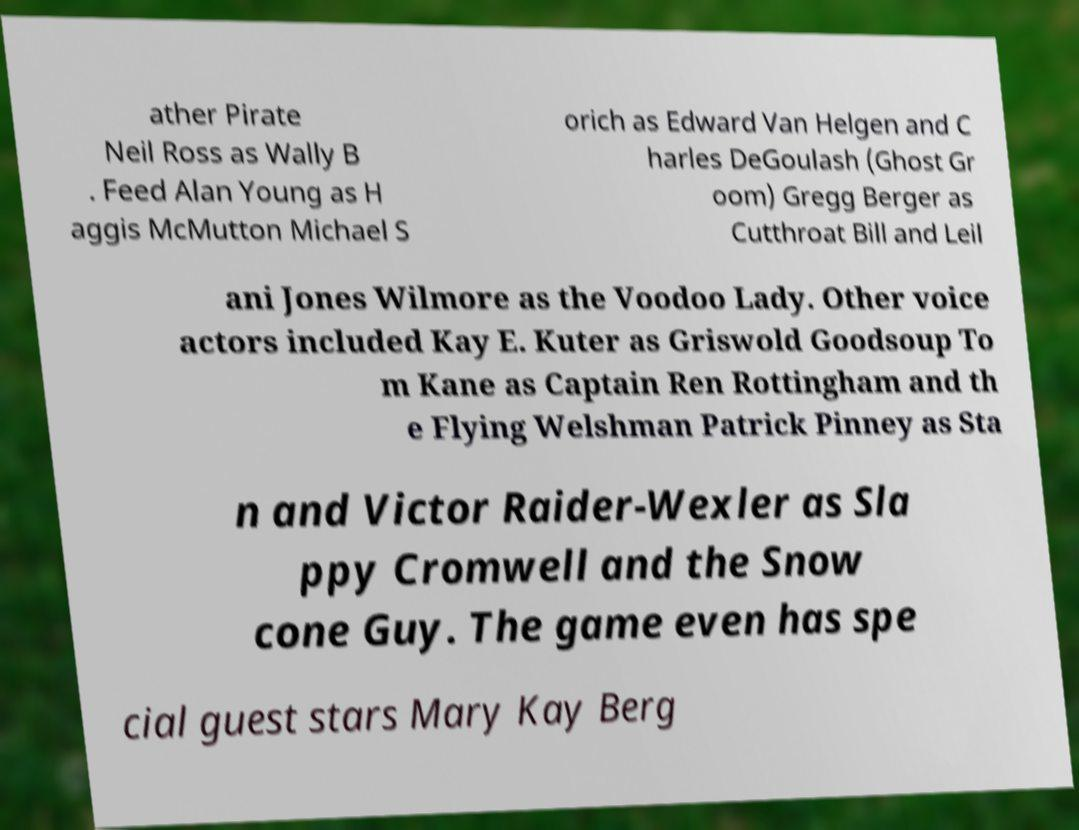Can you accurately transcribe the text from the provided image for me? ather Pirate Neil Ross as Wally B . Feed Alan Young as H aggis McMutton Michael S orich as Edward Van Helgen and C harles DeGoulash (Ghost Gr oom) Gregg Berger as Cutthroat Bill and Leil ani Jones Wilmore as the Voodoo Lady. Other voice actors included Kay E. Kuter as Griswold Goodsoup To m Kane as Captain Ren Rottingham and th e Flying Welshman Patrick Pinney as Sta n and Victor Raider-Wexler as Sla ppy Cromwell and the Snow cone Guy. The game even has spe cial guest stars Mary Kay Berg 